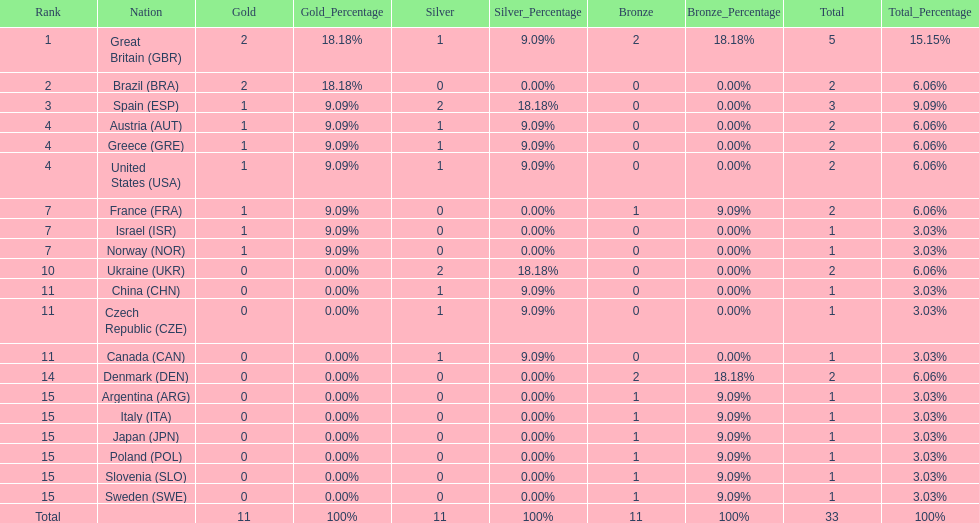What country had the most medals? Great Britain. 